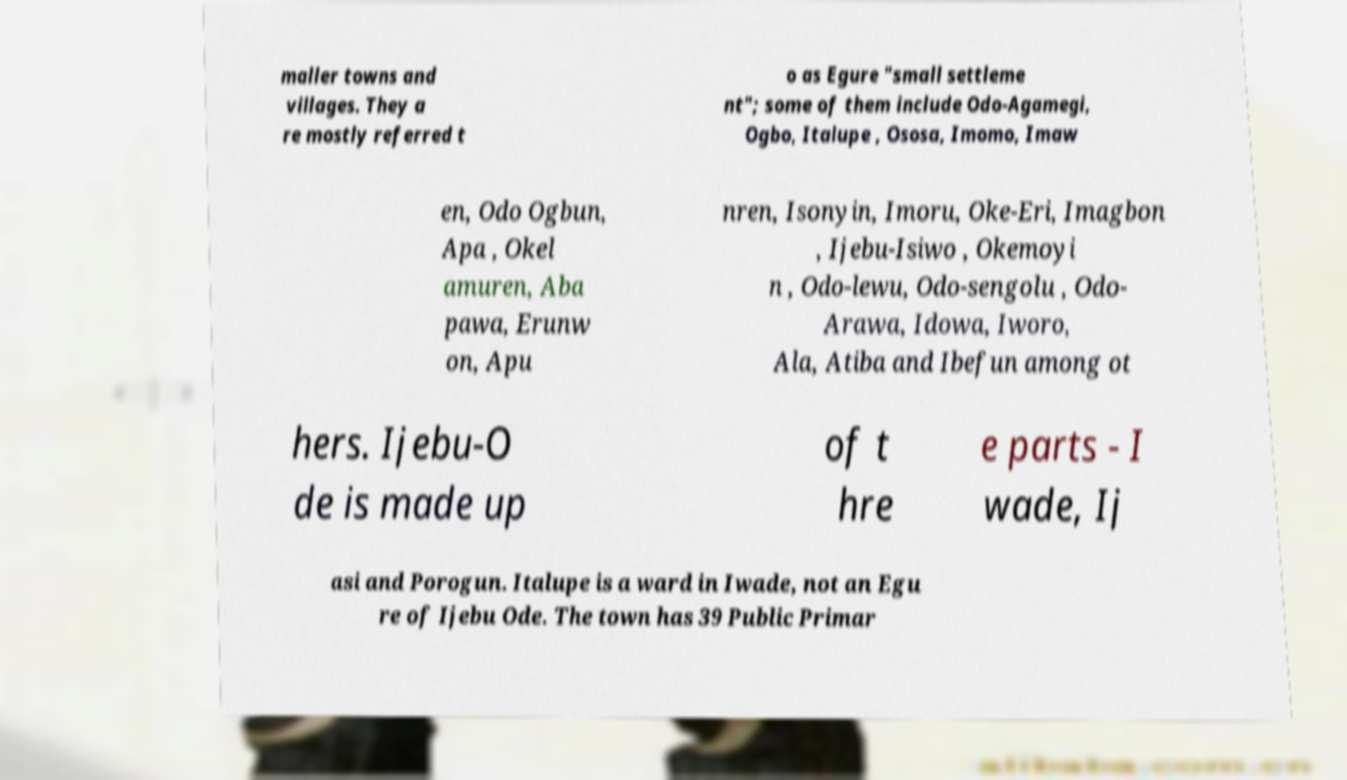I need the written content from this picture converted into text. Can you do that? maller towns and villages. They a re mostly referred t o as Egure "small settleme nt"; some of them include Odo-Agamegi, Ogbo, Italupe , Ososa, Imomo, Imaw en, Odo Ogbun, Apa , Okel amuren, Aba pawa, Erunw on, Apu nren, Isonyin, Imoru, Oke-Eri, Imagbon , Ijebu-Isiwo , Okemoyi n , Odo-lewu, Odo-sengolu , Odo- Arawa, Idowa, Iworo, Ala, Atiba and Ibefun among ot hers. Ijebu-O de is made up of t hre e parts - I wade, Ij asi and Porogun. Italupe is a ward in Iwade, not an Egu re of Ijebu Ode. The town has 39 Public Primar 